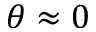Convert formula to latex. <formula><loc_0><loc_0><loc_500><loc_500>\theta \approx 0</formula> 